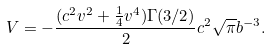<formula> <loc_0><loc_0><loc_500><loc_500>V = - \frac { ( c ^ { 2 } v ^ { 2 } + \frac { 1 } { 4 } v ^ { 4 } ) \Gamma ( 3 / 2 ) } 2 c ^ { 2 } \sqrt { \pi } b ^ { - 3 } .</formula> 